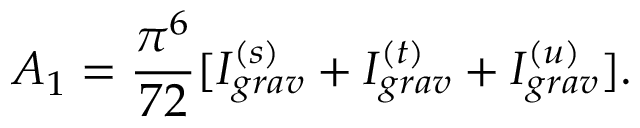Convert formula to latex. <formula><loc_0><loc_0><loc_500><loc_500>A _ { 1 } = \frac { \pi ^ { 6 } } { 7 2 } [ I _ { g r a v } ^ { ( s ) } + I _ { g r a v } ^ { ( t ) } + I _ { g r a v } ^ { ( u ) } ] .</formula> 